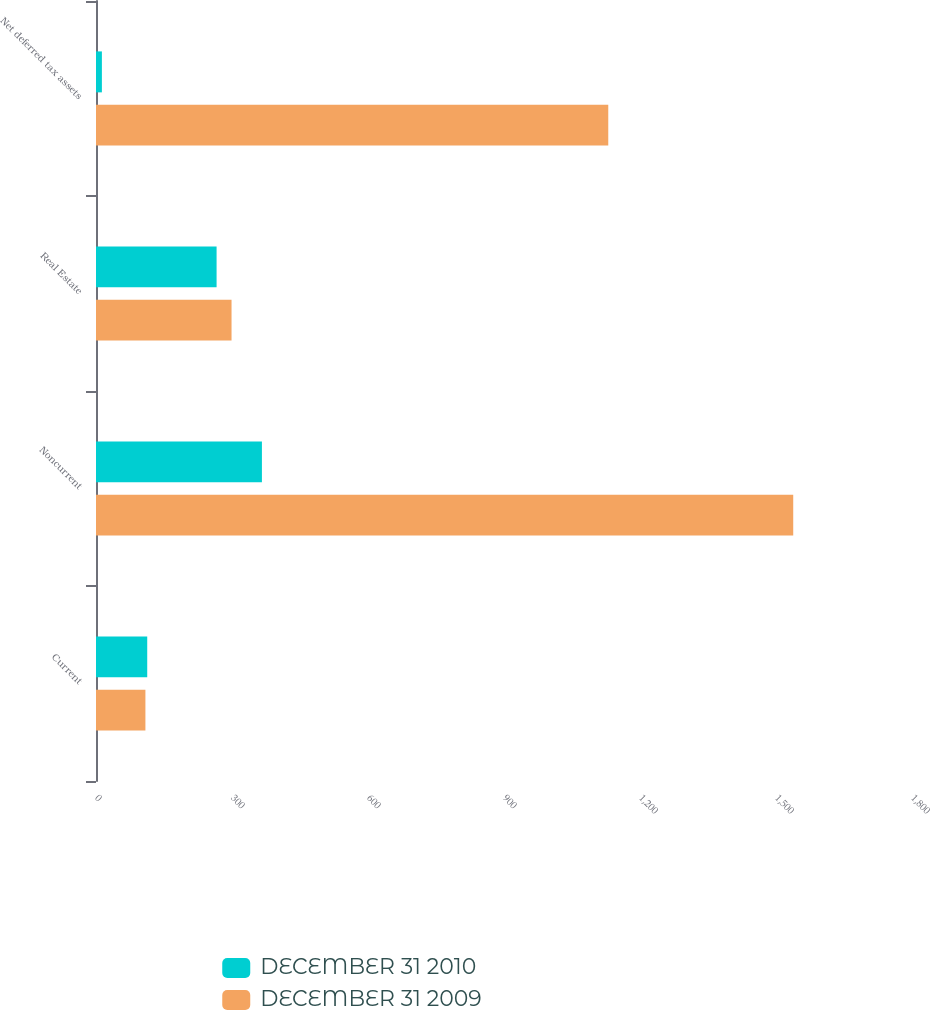Convert chart to OTSL. <chart><loc_0><loc_0><loc_500><loc_500><stacked_bar_chart><ecel><fcel>Current<fcel>Noncurrent<fcel>Real Estate<fcel>Net deferred tax assets<nl><fcel>DECEMBER 31 2010<fcel>113<fcel>366<fcel>266<fcel>13<nl><fcel>DECEMBER 31 2009<fcel>109<fcel>1538<fcel>299<fcel>1130<nl></chart> 